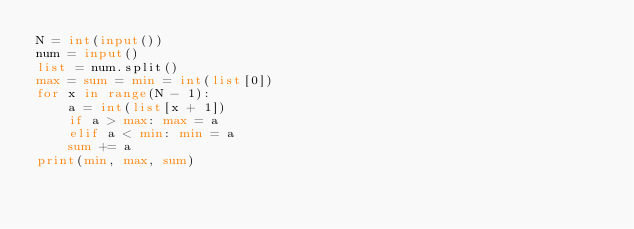<code> <loc_0><loc_0><loc_500><loc_500><_Python_>N = int(input())
num = input()
list = num.split()
max = sum = min = int(list[0])
for x in range(N - 1):
    a = int(list[x + 1])
    if a > max: max = a
    elif a < min: min = a
    sum += a
print(min, max, sum)
    

</code> 